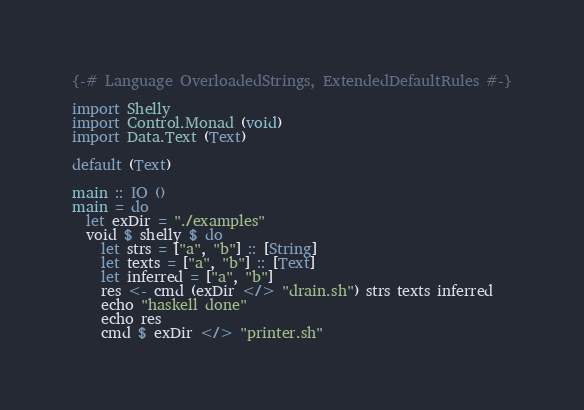<code> <loc_0><loc_0><loc_500><loc_500><_Haskell_>{-# Language OverloadedStrings, ExtendedDefaultRules #-}

import Shelly
import Control.Monad (void)
import Data.Text (Text)

default (Text)

main :: IO ()
main = do
  let exDir = "./examples"
  void $ shelly $ do
    let strs = ["a", "b"] :: [String]
    let texts = ["a", "b"] :: [Text]
    let inferred = ["a", "b"]
    res <- cmd (exDir </> "drain.sh") strs texts inferred
    echo "haskell done"
    echo res
    cmd $ exDir </> "printer.sh"
</code> 